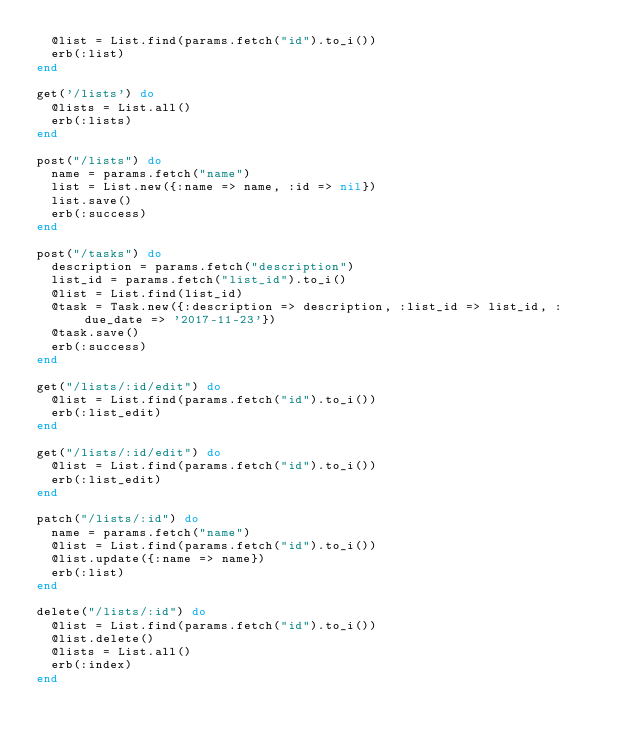<code> <loc_0><loc_0><loc_500><loc_500><_Ruby_>  @list = List.find(params.fetch("id").to_i())
  erb(:list)
end

get('/lists') do
  @lists = List.all()
  erb(:lists)
end

post("/lists") do
  name = params.fetch("name")
  list = List.new({:name => name, :id => nil})
  list.save()
  erb(:success)
end

post("/tasks") do
  description = params.fetch("description")
  list_id = params.fetch("list_id").to_i()
  @list = List.find(list_id)
  @task = Task.new({:description => description, :list_id => list_id, :due_date => '2017-11-23'})
  @task.save()
  erb(:success)
end

get("/lists/:id/edit") do
  @list = List.find(params.fetch("id").to_i())
  erb(:list_edit)
end

get("/lists/:id/edit") do
  @list = List.find(params.fetch("id").to_i())
  erb(:list_edit)
end

patch("/lists/:id") do
  name = params.fetch("name")
  @list = List.find(params.fetch("id").to_i())
  @list.update({:name => name})
  erb(:list)
end

delete("/lists/:id") do
  @list = List.find(params.fetch("id").to_i())
  @list.delete()
  @lists = List.all()
  erb(:index)
end
</code> 